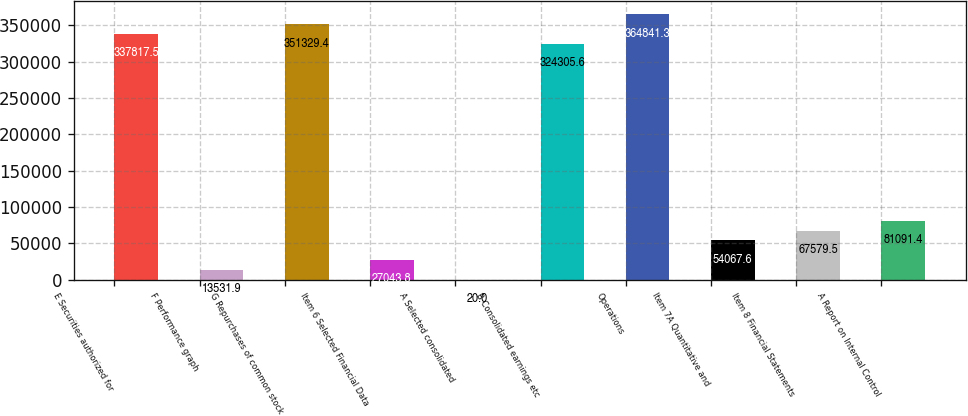Convert chart. <chart><loc_0><loc_0><loc_500><loc_500><bar_chart><fcel>E Securities authorized for<fcel>F Performance graph<fcel>G Repurchases of common stock<fcel>Item 6 Selected Financial Data<fcel>A Selected consolidated<fcel>B Consolidated earnings etc<fcel>Operations<fcel>Item 7A Quantitative and<fcel>Item 8 Financial Statements<fcel>A Report on Internal Control<nl><fcel>337818<fcel>13531.9<fcel>351329<fcel>27043.8<fcel>20<fcel>324306<fcel>364841<fcel>54067.6<fcel>67579.5<fcel>81091.4<nl></chart> 